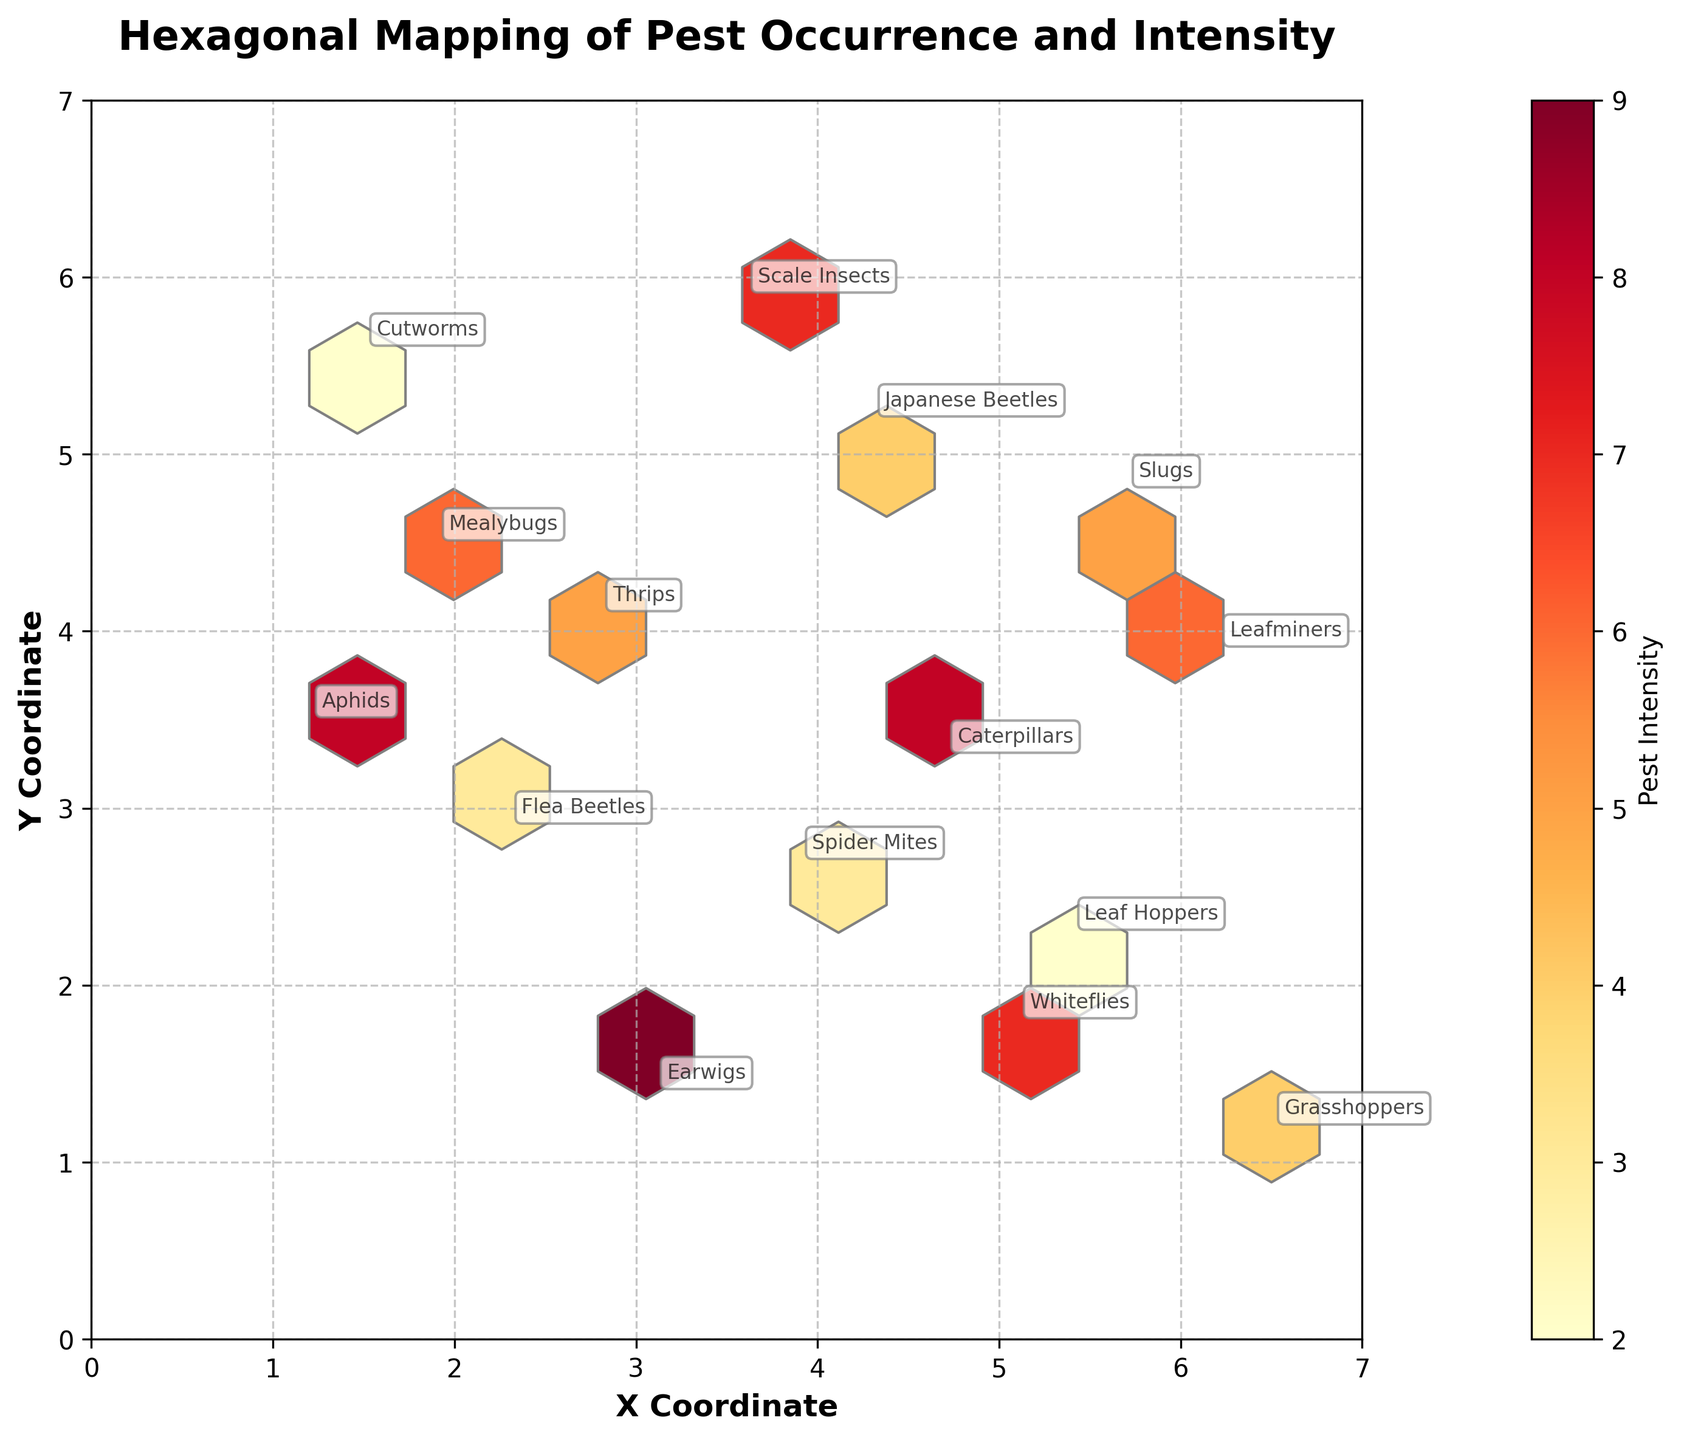What is the title of the hexbin plot? The title of the plot is written at the top of the figure in bold text.
Answer: Hexagonal Mapping of Pest Occurrence and Intensity What does the color intensity on the hexbin plot represent? The color intensity on the plot is explained by the color bar which indicates pest intensity.
Answer: Pest intensity How many different types of pests are annotated in the plot? By counting each unique label next to the points, we can determine the number of different types of pests.
Answer: 15 Which pest type is located near the coordinates (1.2, 3.5)? Finding the pest type annotated next to the coordinates (1.2, 3.5), we can identify it.
Answer: Aphids What are the x and y-axis labels of the hexbin plot? The axes labels are written along the horizontal and vertical sides of the plot, respectively.
Answer: X Coordinate, Y Coordinate Which area on the plot has the highest pest intensity based on the color intensity of hexagons? The darkest colored hexagon, indicating the highest pest intensity, can be identified by examining the colors.
Answer: Around coordinates (3.1, 1.4) Compare the pest intensity at coordinates (3.9, 2.7) and (6.2, 3.9). Which is higher? Looking at the color intensity of the hexagons around these coordinates, we can compare the values.
Answer: 6.2, 3.9 is higher How does the pest intensity vary between the coordinates (1.5, 5.6) and (4.7, 3.3)? By comparing the color depth of hexagons around these points, we can see which has a higher pest intensity.
Answer: 4.7, 3.3 has a higher intensity Are there any pest types located near the middle of the plot, around coordinates (3.5, 3.5)? Checking the annotations near this point can confirm the presence of pest types.
Answer: No, there is no pest type exactly at (3.5, 3.5) Is the variation of pest occurrence uniformly distributed across the plot? By examining if hexagons show similar color intensity throughout the plot, we can see the distribution pattern.
Answer: No, it varies significantly 